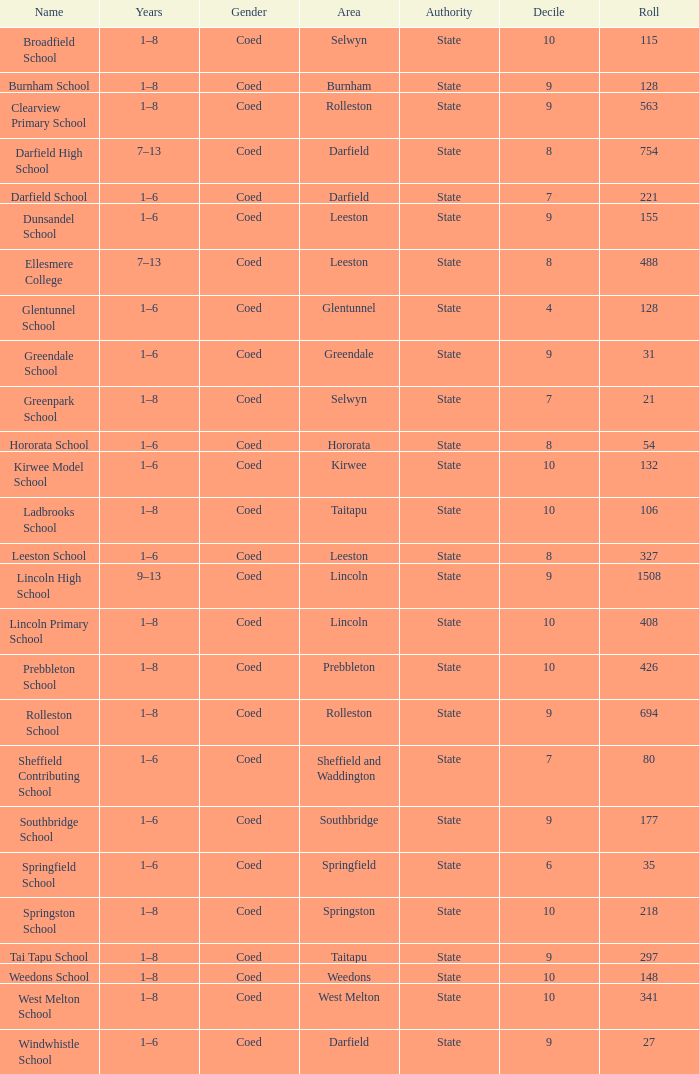What is the number of deciles included in years of 9-13? 1.0. 